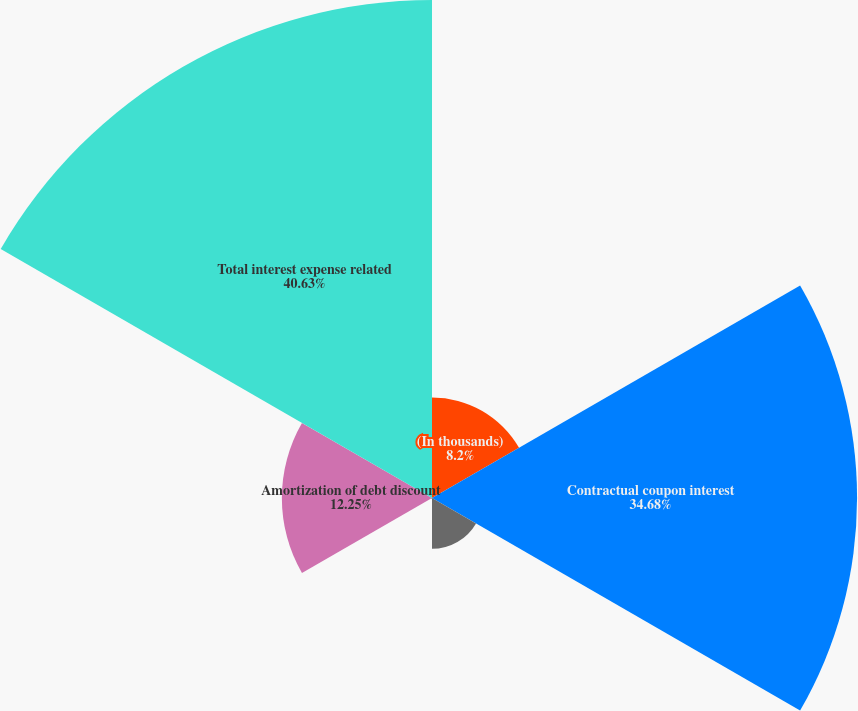<chart> <loc_0><loc_0><loc_500><loc_500><pie_chart><fcel>(In thousands)<fcel>Contractual coupon interest<fcel>Amortization of debt issuance<fcel>Amortization of embedded<fcel>Amortization of debt discount<fcel>Total interest expense related<nl><fcel>8.2%<fcel>34.68%<fcel>4.15%<fcel>0.09%<fcel>12.25%<fcel>40.63%<nl></chart> 